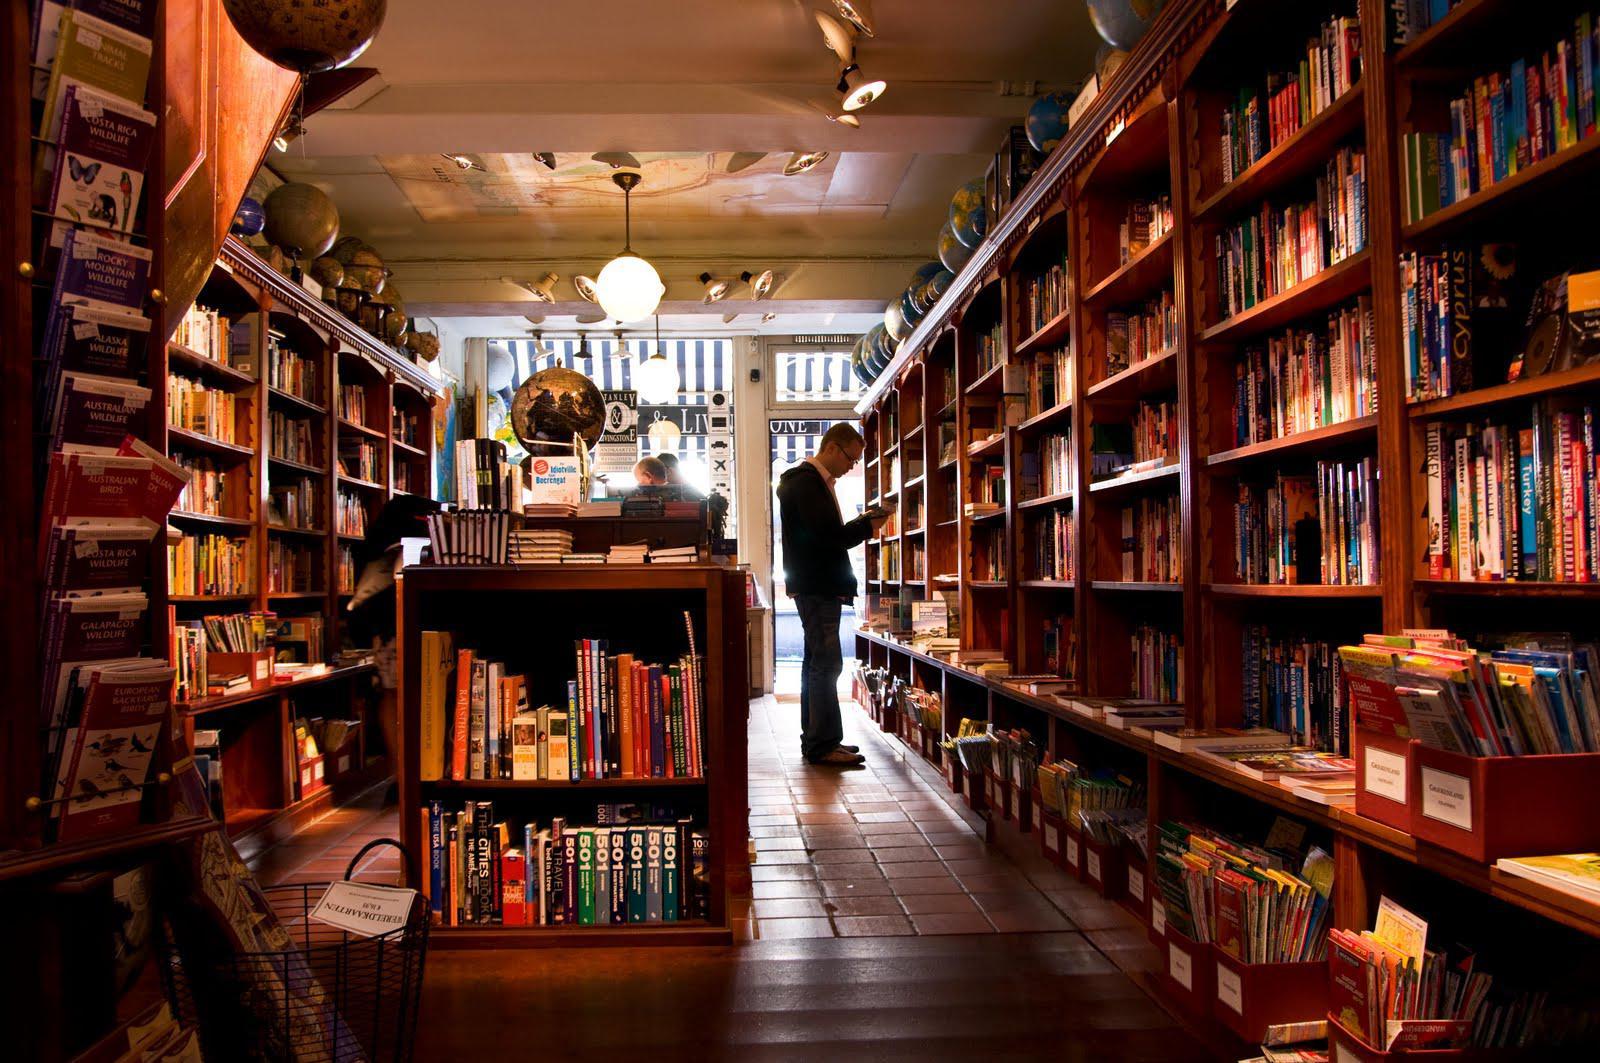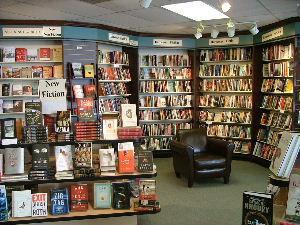The first image is the image on the left, the second image is the image on the right. For the images displayed, is the sentence "At least one image is inside the store, and there is a window you can see out of." factually correct? Answer yes or no. Yes. 